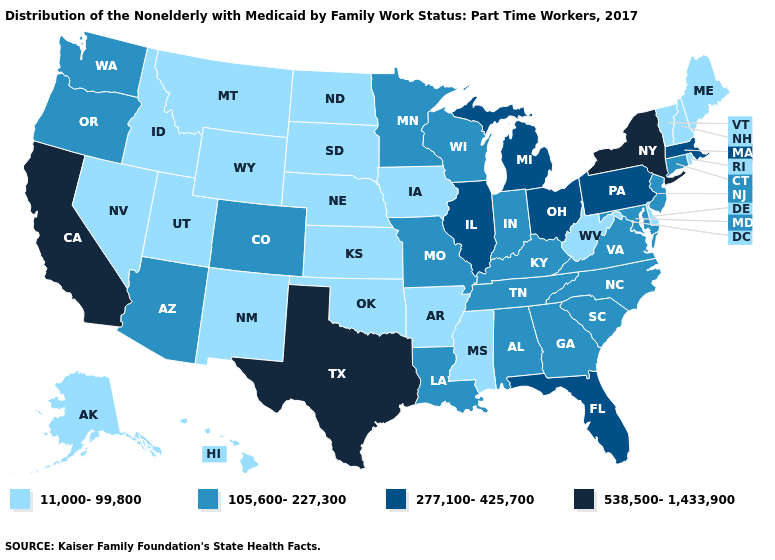What is the value of Oregon?
Quick response, please. 105,600-227,300. Which states have the highest value in the USA?
Short answer required. California, New York, Texas. Does Vermont have the lowest value in the Northeast?
Concise answer only. Yes. What is the lowest value in the USA?
Quick response, please. 11,000-99,800. What is the highest value in states that border Arkansas?
Short answer required. 538,500-1,433,900. Among the states that border Texas , which have the highest value?
Write a very short answer. Louisiana. Does New York have the highest value in the USA?
Short answer required. Yes. Does Georgia have a lower value than Colorado?
Concise answer only. No. Name the states that have a value in the range 105,600-227,300?
Be succinct. Alabama, Arizona, Colorado, Connecticut, Georgia, Indiana, Kentucky, Louisiana, Maryland, Minnesota, Missouri, New Jersey, North Carolina, Oregon, South Carolina, Tennessee, Virginia, Washington, Wisconsin. Among the states that border Connecticut , does Massachusetts have the highest value?
Concise answer only. No. Does North Carolina have the same value as Maine?
Keep it brief. No. What is the value of New Mexico?
Keep it brief. 11,000-99,800. Name the states that have a value in the range 11,000-99,800?
Quick response, please. Alaska, Arkansas, Delaware, Hawaii, Idaho, Iowa, Kansas, Maine, Mississippi, Montana, Nebraska, Nevada, New Hampshire, New Mexico, North Dakota, Oklahoma, Rhode Island, South Dakota, Utah, Vermont, West Virginia, Wyoming. How many symbols are there in the legend?
Answer briefly. 4. Name the states that have a value in the range 538,500-1,433,900?
Concise answer only. California, New York, Texas. 